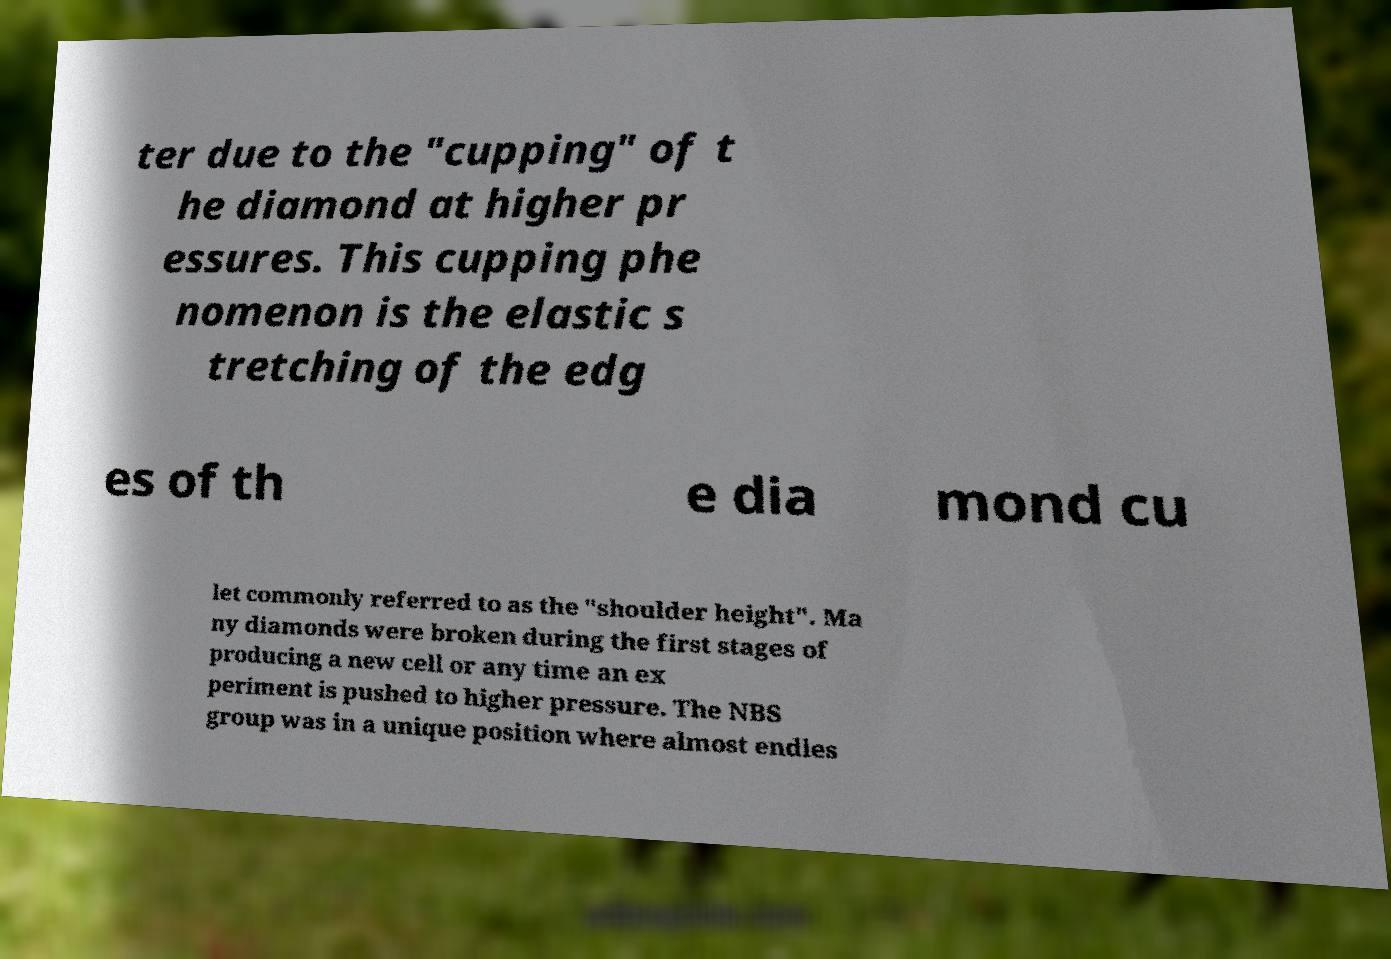For documentation purposes, I need the text within this image transcribed. Could you provide that? ter due to the "cupping" of t he diamond at higher pr essures. This cupping phe nomenon is the elastic s tretching of the edg es of th e dia mond cu let commonly referred to as the "shoulder height". Ma ny diamonds were broken during the first stages of producing a new cell or any time an ex periment is pushed to higher pressure. The NBS group was in a unique position where almost endles 